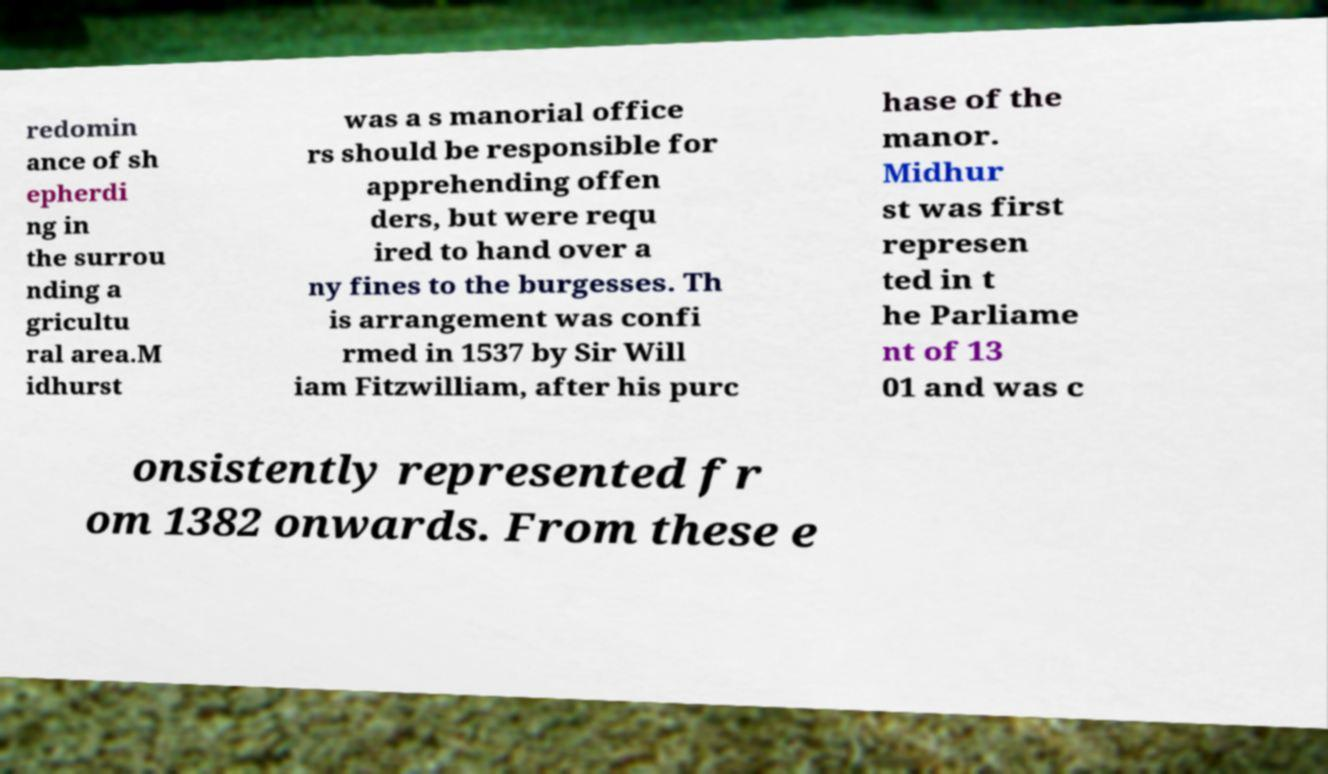Please read and relay the text visible in this image. What does it say? redomin ance of sh epherdi ng in the surrou nding a gricultu ral area.M idhurst was a s manorial office rs should be responsible for apprehending offen ders, but were requ ired to hand over a ny fines to the burgesses. Th is arrangement was confi rmed in 1537 by Sir Will iam Fitzwilliam, after his purc hase of the manor. Midhur st was first represen ted in t he Parliame nt of 13 01 and was c onsistently represented fr om 1382 onwards. From these e 